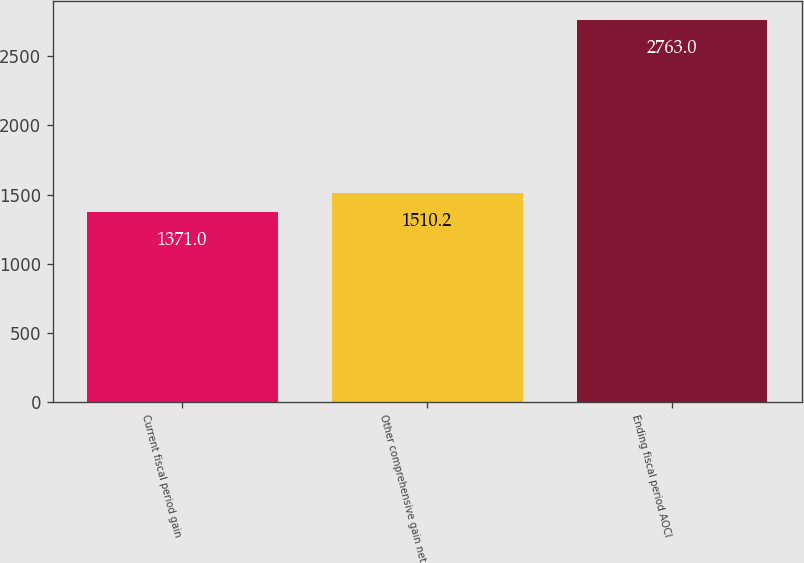Convert chart to OTSL. <chart><loc_0><loc_0><loc_500><loc_500><bar_chart><fcel>Current fiscal period gain<fcel>Other comprehensive gain net<fcel>Ending fiscal period AOCI<nl><fcel>1371<fcel>1510.2<fcel>2763<nl></chart> 